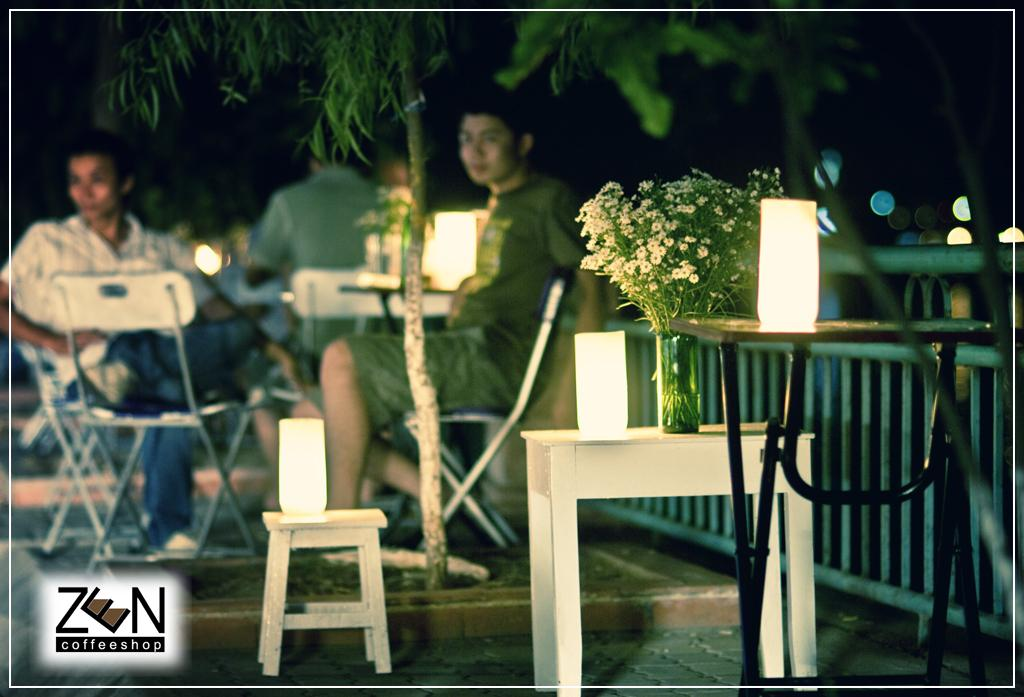What are the people in the image doing? The people in the image are sitting on chairs. What is present on the table in the image? There is a table in the image, and on it, there are lights and a plant. What can be seen in the background of the image? There are trees visible in the image. What type of form is being filled out by the people sitting on chairs in the image? There is no form present in the image; the people are simply sitting on chairs. 